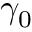<formula> <loc_0><loc_0><loc_500><loc_500>\gamma _ { 0 }</formula> 